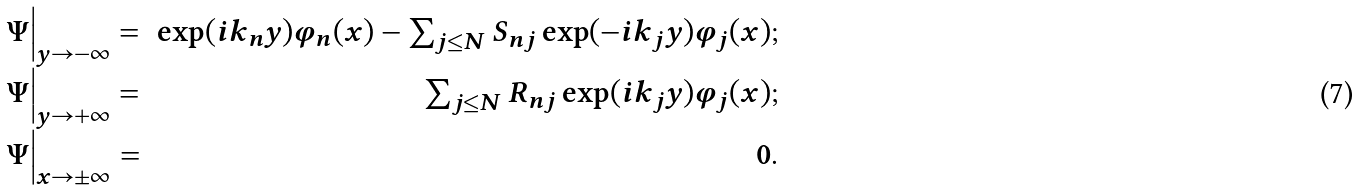Convert formula to latex. <formula><loc_0><loc_0><loc_500><loc_500>\begin{array} { l r } { { \Psi \Big | _ { y \to - \infty } = } } & { { \exp ( i k _ { n } y ) \varphi _ { n } ( x ) - \sum _ { j \leq N } S _ { n j } \exp ( - i k _ { j } y ) \varphi _ { j } ( x ) ; } } \\ { { \Psi \Big | _ { y \to + \infty } = } } & { { \sum _ { j \leq N } R _ { n j } \exp ( i k _ { j } y ) \varphi _ { j } ( x ) ; } } \\ { { \Psi \Big | _ { x \to \pm \infty } = } } & { 0 . } \end{array}</formula> 